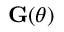Convert formula to latex. <formula><loc_0><loc_0><loc_500><loc_500>\mathbf G ( \theta )</formula> 